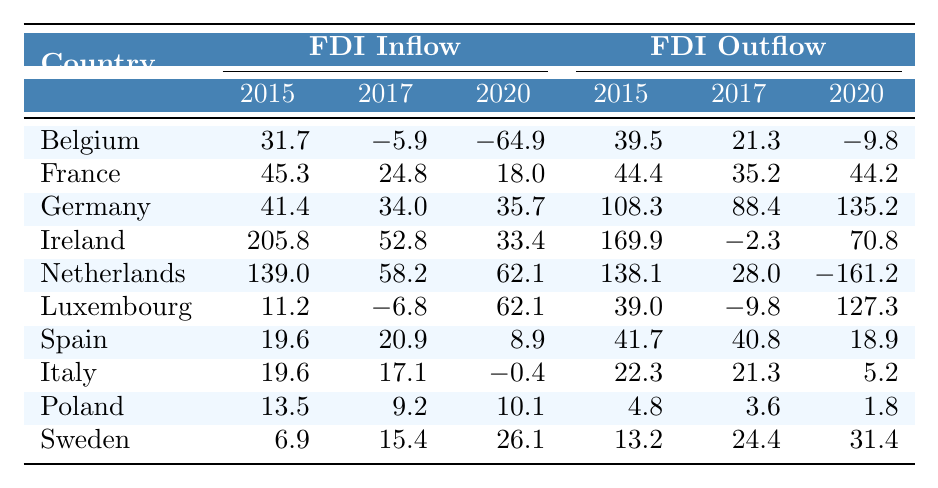What was the FDI inflow for Germany in 2020? The value for Germany under the FDI inflow in 2020 is 35.7.
Answer: 35.7 How much did FDI inflow decrease for Belgium from 2015 to 2020? The FDI inflow for Belgium in 2015 was 31.7, and in 2020 it was -64.9. The decrease is calculated as -64.9 - 31.7 = -96.6.
Answer: -96.6 Did Luxembourg experience an increase in FDI inflow from 2017 to 2020? Luxembourg's FDI inflow for 2017 was -6.8 and for 2020 it was 62.1, which shows an increase.
Answer: Yes What is the average FDI inflow for Spain over the years listed? The years listed are 2015, 2017, and 2020, with inflows of 19.6, 20.9, and 8.9 respectively. Calculating the average: (19.6 + 20.9 + 8.9) / 3 = 49.4 / 3 = 16.47.
Answer: 16.47 What is the change in FDI outflow for France from 2015 to 2020? The FDI outflow for France in 2015 was 44.4, and in 2020 it was 44.2. The change is 44.2 - 44.4 = -0.2.
Answer: -0.2 Which country had the highest FDI inflow in 2019? The FDI inflow for the Netherlands in 2019 was the highest at 860.5.
Answer: Netherlands Is it true that FDI outflow in Germany decreased from 2015 to 2020? FDI outflow for Germany in 2015 was 108.3 and in 2020 it was 135.2, indicating an increase rather than a decrease.
Answer: No What is the total FDI inflow for Ireland over the years listed? The FDI inflow for Ireland in the years 2015, 2017, and 2020 is 205.8, 52.8, and 33.4 respectively. The total is 205.8 + 52.8 + 33.4 = 292.0.
Answer: 292.0 What percentage of FDI inflow did Sweden see in 2020 compared to its 2015 value? Sweden's FDI inflow in 2015 was 6.9 and in 2020 it was 26.1. The percentage increase is ((26.1 - 6.9) / 6.9) * 100 = 278.3%.
Answer: 278.3% Which country had the least negative FDI inflow in 2020? Comparing the 2020 FDI inflows, the least negative is for Luxembourg at 62.1.
Answer: Luxembourg 